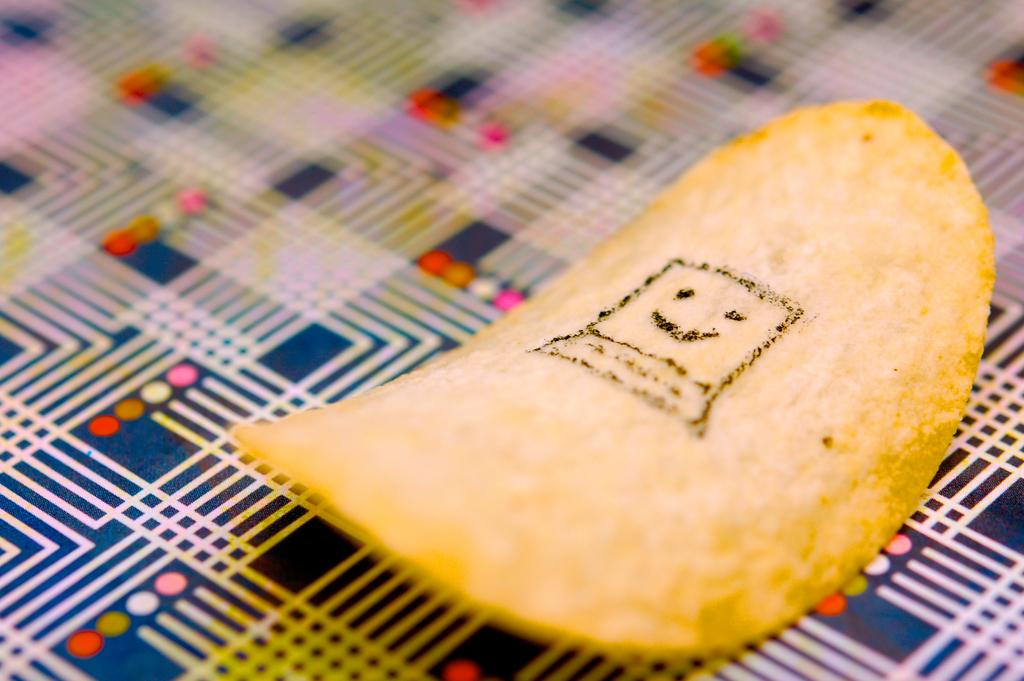What is the unusual feature of the potato chip in the image? The potato chip in the image has black paint on it. What else can be seen in the image besides the potato chip? There is a cloth in the image. What is the price of the sisters in the image? There are no sisters or price mentioned in the image; it only features a potato chip with black paint and a cloth. 